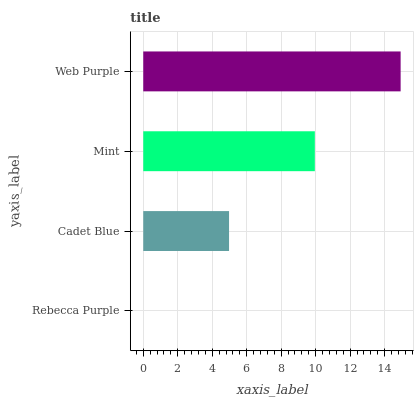Is Rebecca Purple the minimum?
Answer yes or no. Yes. Is Web Purple the maximum?
Answer yes or no. Yes. Is Cadet Blue the minimum?
Answer yes or no. No. Is Cadet Blue the maximum?
Answer yes or no. No. Is Cadet Blue greater than Rebecca Purple?
Answer yes or no. Yes. Is Rebecca Purple less than Cadet Blue?
Answer yes or no. Yes. Is Rebecca Purple greater than Cadet Blue?
Answer yes or no. No. Is Cadet Blue less than Rebecca Purple?
Answer yes or no. No. Is Mint the high median?
Answer yes or no. Yes. Is Cadet Blue the low median?
Answer yes or no. Yes. Is Rebecca Purple the high median?
Answer yes or no. No. Is Rebecca Purple the low median?
Answer yes or no. No. 